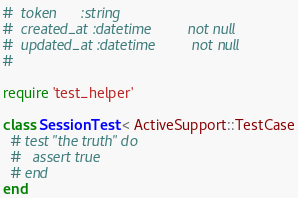<code> <loc_0><loc_0><loc_500><loc_500><_Ruby_>#  token      :string
#  created_at :datetime         not null
#  updated_at :datetime         not null
#

require 'test_helper'

class SessionTest < ActiveSupport::TestCase
  # test "the truth" do
  #   assert true
  # end
end
</code> 